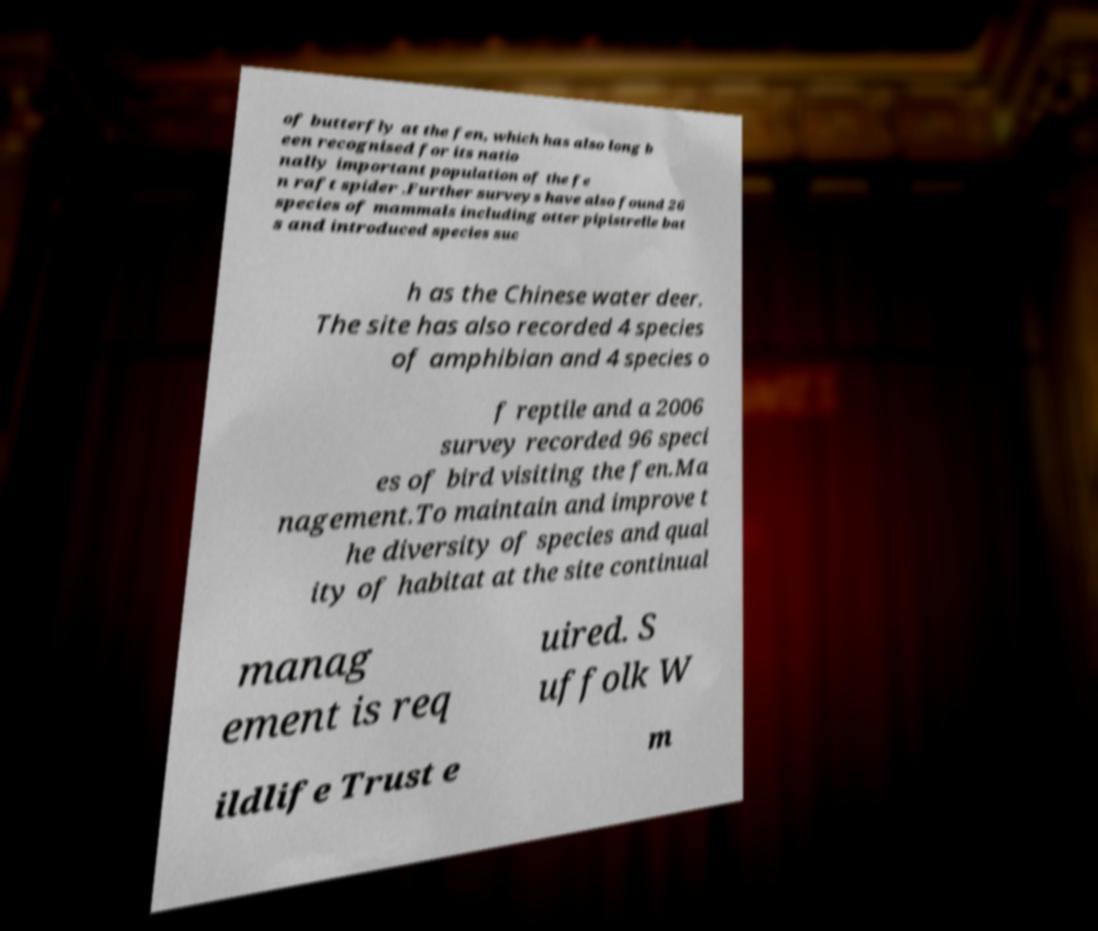Can you read and provide the text displayed in the image?This photo seems to have some interesting text. Can you extract and type it out for me? of butterfly at the fen, which has also long b een recognised for its natio nally important population of the fe n raft spider .Further surveys have also found 26 species of mammals including otter pipistrelle bat s and introduced species suc h as the Chinese water deer. The site has also recorded 4 species of amphibian and 4 species o f reptile and a 2006 survey recorded 96 speci es of bird visiting the fen.Ma nagement.To maintain and improve t he diversity of species and qual ity of habitat at the site continual manag ement is req uired. S uffolk W ildlife Trust e m 